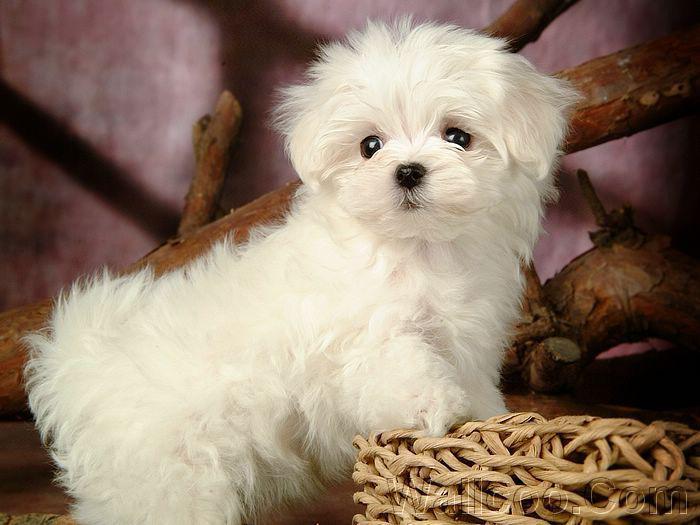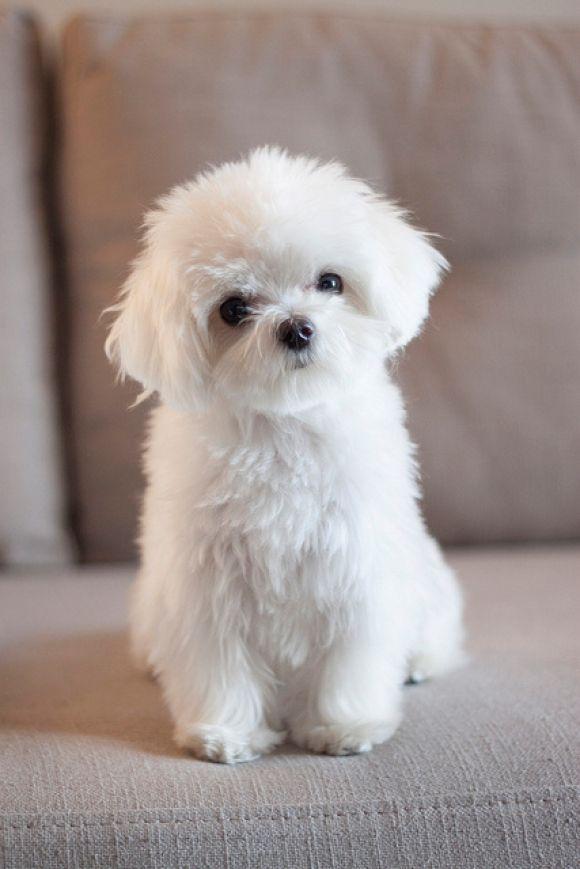The first image is the image on the left, the second image is the image on the right. Evaluate the accuracy of this statement regarding the images: "A total of three white dogs are shown, and the two dogs in one image are lookalikes, but do not closely resemble the lone dog in the other image.". Is it true? Answer yes or no. No. The first image is the image on the left, the second image is the image on the right. Given the left and right images, does the statement "At least one dog has its mouth open." hold true? Answer yes or no. No. 